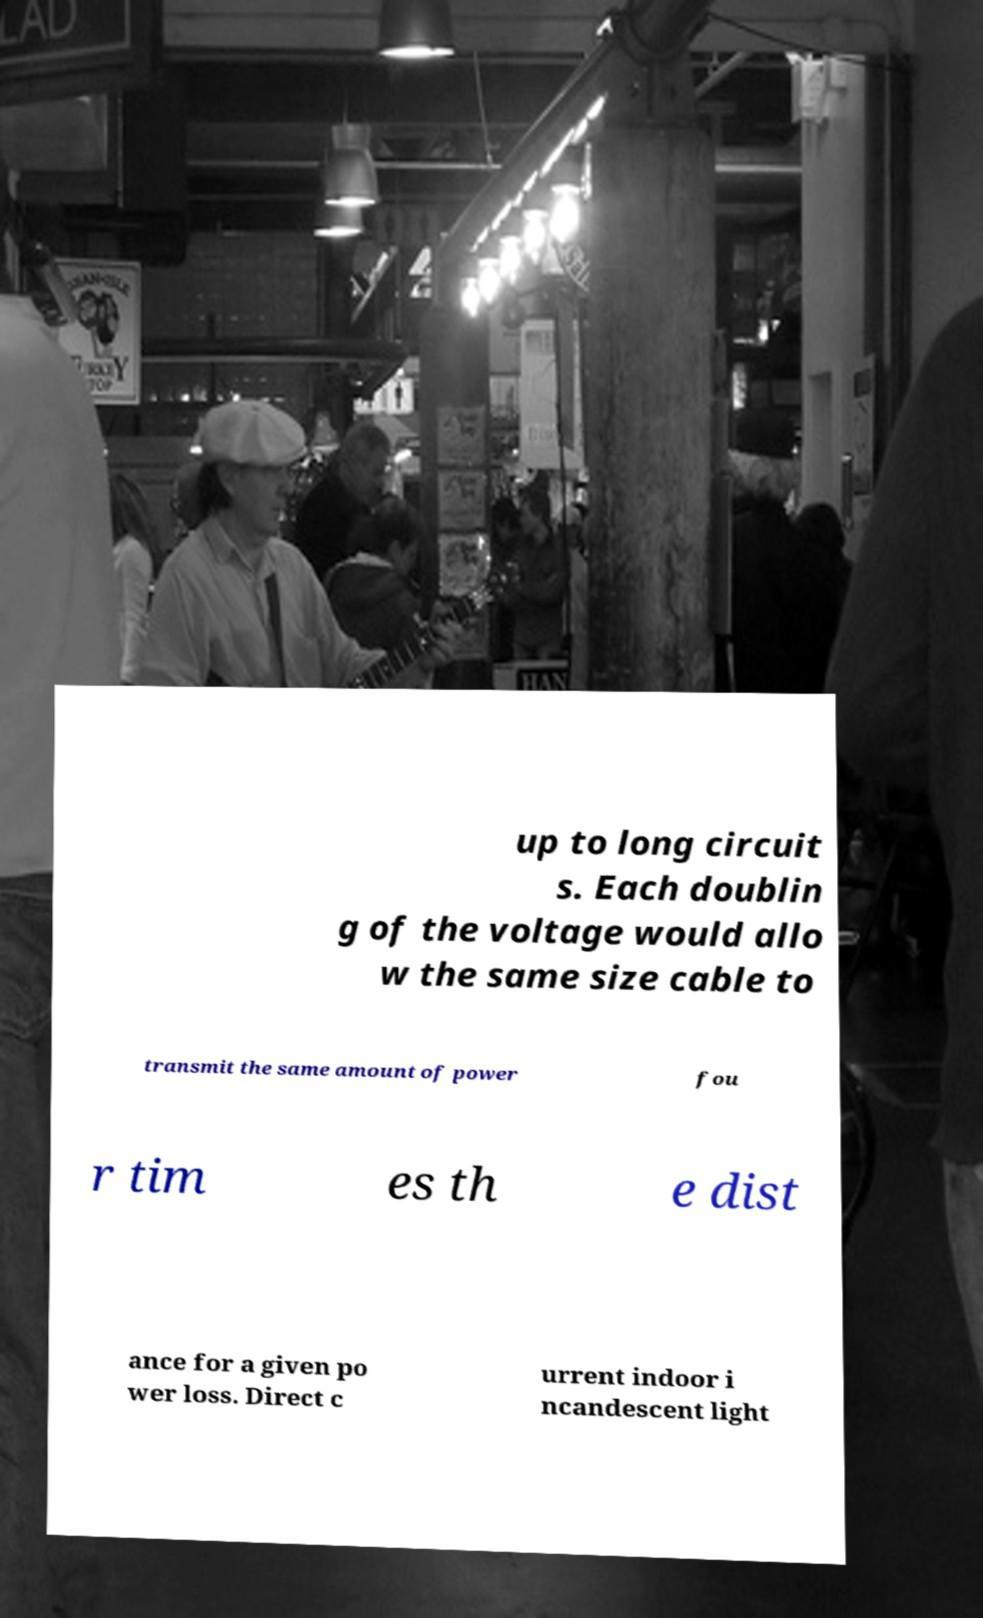Please read and relay the text visible in this image. What does it say? up to long circuit s. Each doublin g of the voltage would allo w the same size cable to transmit the same amount of power fou r tim es th e dist ance for a given po wer loss. Direct c urrent indoor i ncandescent light 